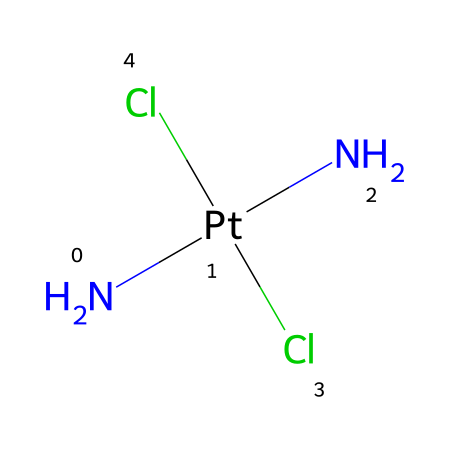What is the central metal ion in this compound? The SMILES representation indicates that platinum (Pt) is the first element listed within the structure, which signifies that it is the central metal ion bonded to the other groups.
Answer: platinum How many chloride ions are present in cisplatin? Looking at the SMILES notation, there are two Cl atoms indicated, indicating the presence of two chloride ions in the structure.
Answer: two What is the coordination number of the central metal ion in this compound? The coordination number corresponds to the number of ligands attached to the central metal. Here, there are four total ligands (two amines and two chlorides), which means the coordination number is four.
Answer: four Which geometry does cisplatin exhibit? Analyzing the structure based on the number of ligands and the arrangement, it can be seen that cisplatin has a square planar geometry due to the arrangement of its four coordinating atoms.
Answer: square planar What functional groups are connected to the platinum ion? In the SMILES representation, we see two amine (N) groups and two chloride (Cl) groups attached to the platinum. This specifies that these are the functional groups connected to the metal ion.
Answer: amine and chloride How does the square planar geometry affect the biological activity of cisplatin? The square planar geometry allows for specific interactions with DNA, enhancing its effectiveness as a chemotherapy drug by causing cross-links, which disrupts cancer cell replication.
Answer: enhances effectiveness 